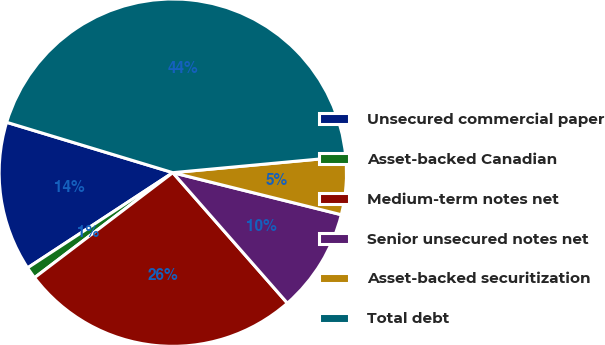Convert chart. <chart><loc_0><loc_0><loc_500><loc_500><pie_chart><fcel>Unsecured commercial paper<fcel>Asset-backed Canadian<fcel>Medium-term notes net<fcel>Senior unsecured notes net<fcel>Asset-backed securitization<fcel>Total debt<nl><fcel>13.92%<fcel>1.1%<fcel>26.13%<fcel>9.64%<fcel>5.37%<fcel>43.84%<nl></chart> 